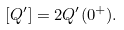<formula> <loc_0><loc_0><loc_500><loc_500>[ Q ^ { \prime } ] = 2 Q ^ { \prime } ( 0 ^ { + } ) .</formula> 